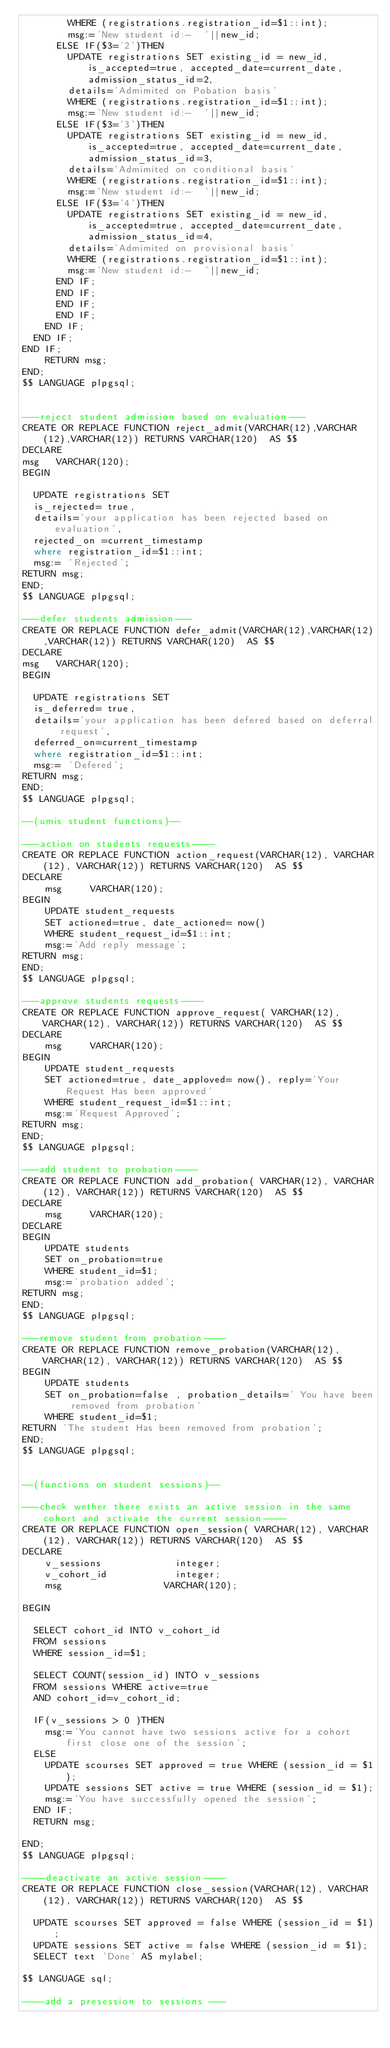Convert code to text. <code><loc_0><loc_0><loc_500><loc_500><_SQL_>				WHERE (registrations.registration_id=$1::int);
				msg:='New student id:-  '||new_id;
			ELSE IF($3='2')THEN
				UPDATE registrations SET existing_id = new_id, is_accepted=true, accepted_date=current_date, admission_status_id=2,
				details='Admimited on Pobation basis'
				WHERE (registrations.registration_id=$1::int);
				msg:='New student id:-  '||new_id;
			ELSE IF($3='3')THEN
				UPDATE registrations SET existing_id = new_id, is_accepted=true, accepted_date=current_date, admission_status_id=3,
				details='Admimited on conditional basis'
				WHERE (registrations.registration_id=$1::int);
				msg:='New student id:-  '||new_id;
			ELSE IF($3='4')THEN
				UPDATE registrations SET existing_id = new_id, is_accepted=true, accepted_date=current_date, admission_status_id=4,
				details='Admimited on provisional basis'
				WHERE (registrations.registration_id=$1::int);
				msg:='New student id:-  '||new_id;
			END IF;
			END IF;
			END IF;
			END IF;
		END IF;
	END IF;
END IF;
    RETURN msg;
END;
$$ LANGUAGE plpgsql;


---reject student admission based on evaluation---  
CREATE OR REPLACE FUNCTION reject_admit(VARCHAR(12),VARCHAR(12),VARCHAR(12)) RETURNS VARCHAR(120)  AS $$
DECLARE
msg		VARCHAR(120);
BEGIN

	UPDATE registrations SET 
	is_rejected= true,
	details='your application has been rejected based on evaluation',
	rejected_on =current_timestamp
	where registration_id=$1::int;
	msg:= 'Rejected';
RETURN msg;
END;
$$ LANGUAGE plpgsql;  

---defer students admission---  
CREATE OR REPLACE FUNCTION defer_admit(VARCHAR(12),VARCHAR(12),VARCHAR(12)) RETURNS VARCHAR(120)  AS $$
DECLARE
msg		VARCHAR(120);
BEGIN

	UPDATE registrations SET 
	is_deferred= true,
	details='your application has been defered based on deferral request',
	deferred_on=current_timestamp
	where registration_id=$1::int;
	msg:= 'Defered';
RETURN msg;
END;
$$ LANGUAGE plpgsql; 

--(umis student functions)--

---action on students requests----
CREATE OR REPLACE FUNCTION action_request(VARCHAR(12), VARCHAR(12), VARCHAR(12)) RETURNS VARCHAR(120)  AS $$
DECLARE 
    msg	    VARCHAR(120);
BEGIN
    UPDATE student_requests
    SET actioned=true, date_actioned= now()
    WHERE student_request_id=$1::int;
    msg:='Add reply message';
RETURN msg;
END;
$$ LANGUAGE plpgsql;
  
---approve students requests----  
CREATE OR REPLACE FUNCTION approve_request( VARCHAR(12), VARCHAR(12), VARCHAR(12)) RETURNS VARCHAR(120)  AS $$
DECLARE 
    msg	    VARCHAR(120);
BEGIN
    UPDATE student_requests
    SET actioned=true, date_apploved= now(), reply='Your Request Has been approved'
    WHERE student_request_id=$1::int;
    msg:='Request Approved';
RETURN msg;
END; 
$$ LANGUAGE plpgsql;
  
---add student to probation----    
CREATE OR REPLACE FUNCTION add_probation( VARCHAR(12), VARCHAR(12), VARCHAR(12)) RETURNS VARCHAR(120)  AS $$
DECLARE
    msg	    VARCHAR(120);
DECLARE 
BEGIN
    UPDATE students
    SET on_probation=true
    WHERE student_id=$1;
    msg:='probation added';
RETURN msg;
END;
$$ LANGUAGE plpgsql;
  
---remove student from probation---- 
CREATE OR REPLACE FUNCTION remove_probation(VARCHAR(12), VARCHAR(12), VARCHAR(12)) RETURNS VARCHAR(120)  AS $$
BEGIN
    UPDATE students
    SET on_probation=false , probation_details=' You have been removed from probation'
    WHERE student_id=$1;
RETURN 'The student Has been removed from probation';
END;
$$ LANGUAGE plpgsql;
  

--(functions on student sessions)--

---check wether there exists an active session in the same cohort and activate the current session---- 				
CREATE OR REPLACE FUNCTION open_session( VARCHAR(12), VARCHAR(12), VARCHAR(12)) RETURNS VARCHAR(120)  AS $$
DECLARE
    v_sessions             integer;
    v_cohort_id	           integer;
    msg		               VARCHAR(120);
    
BEGIN

	SELECT cohort_id INTO v_cohort_id 
	FROM sessions
	WHERE session_id=$1;
	
	SELECT COUNT(session_id) INTO v_sessions
	FROM sessions WHERE active=true
	AND cohort_id=v_cohort_id;

	IF(v_sessions > 0 )THEN
		msg:='You cannot have two sessions active for a cohort first close one of the session';
	ELSE
		UPDATE scourses SET approved = true WHERE (session_id = $1);
		UPDATE sessions SET active = true WHERE (session_id = $1);
		msg:='You have successfully opened the session';
	END IF;
	RETURN msg;
	
END;
$$ LANGUAGE plpgsql;
  
----deactivate an active session----
CREATE OR REPLACE FUNCTION close_session(VARCHAR(12), VARCHAR(12), VARCHAR(12)) RETURNS VARCHAR(120)  AS $$

	UPDATE scourses SET approved = false WHERE (session_id = $1);
	UPDATE sessions SET active = false WHERE (session_id = $1);
	SELECT text 'Done' AS mylabel;
	
$$ LANGUAGE sql;

----add a presession to sessions ---</code> 